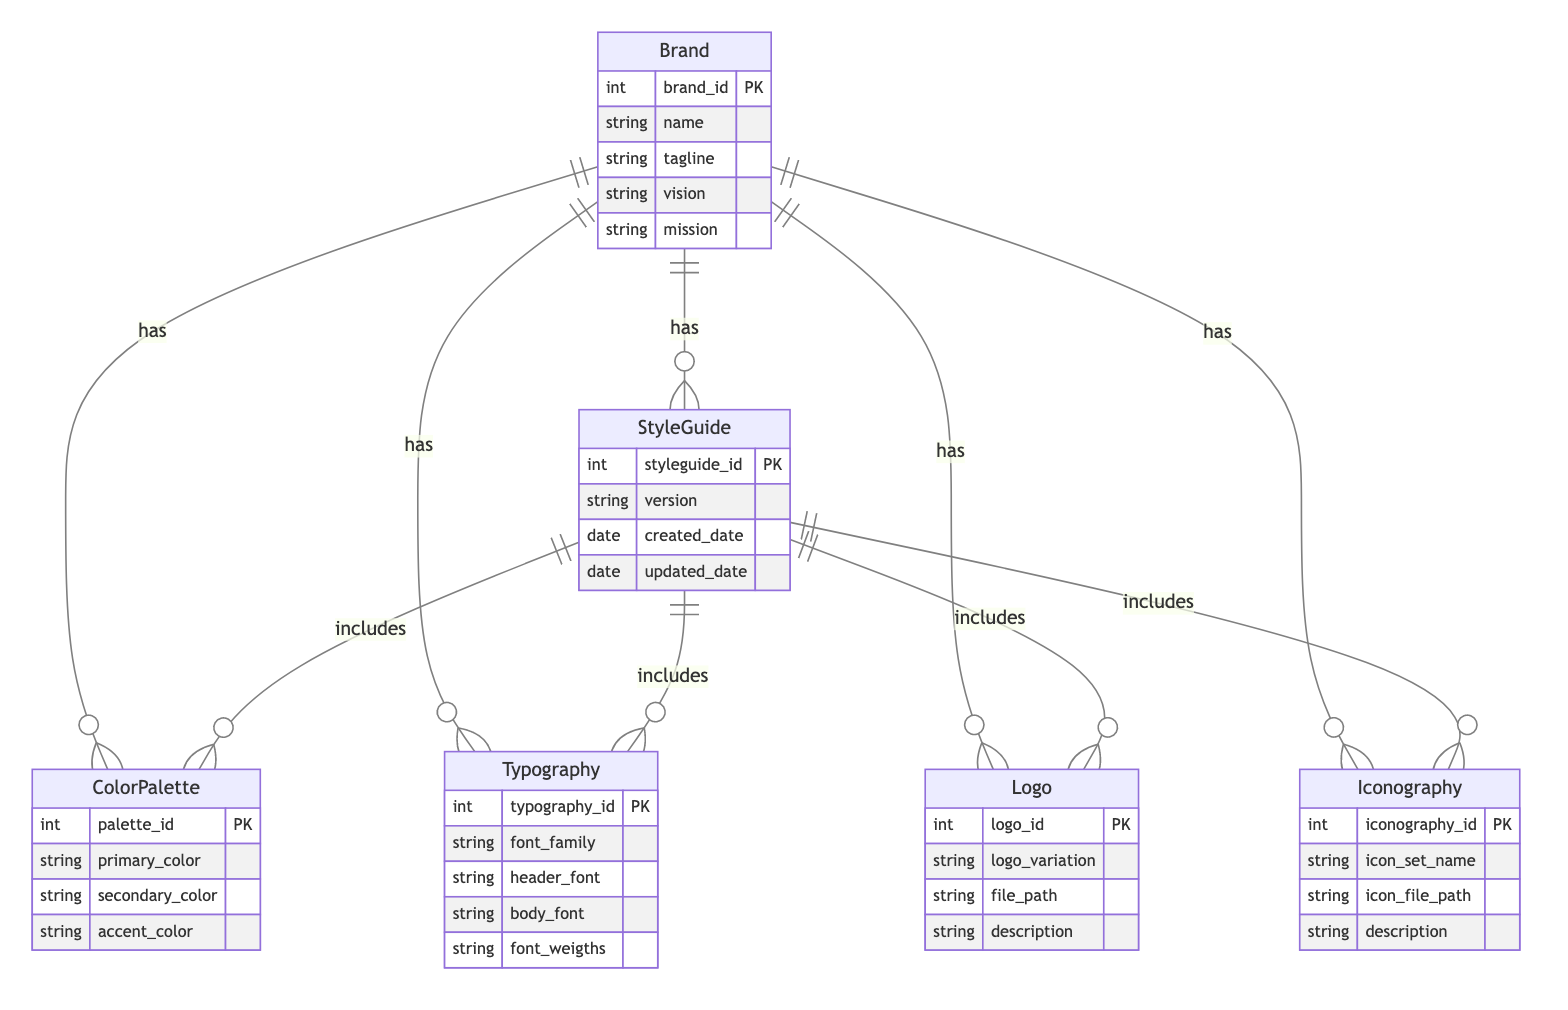What is the primary key of the Brand entity? The primary key of the Brand entity is "brand_id," which uniquely identifies each brand in the database, as indicated in the diagram.
Answer: brand_id How many entities are present in the diagram? The diagram has six entities: Brand, ColorPalette, Typography, Logo, Iconography, and StyleGuide, making a total of six entities.
Answer: six What relationship type exists between Brand and Logo? The relationship between Brand and Logo is one-to-many, meaning one brand can have multiple logos associated with it, as shown in the diagram.
Answer: one-to-many Which entity does the StyleGuide relationship "includes" ColorPalette link back to? The "includes" relationship from ColorPalette links back to the StyleGuide entity, indicating that StyleGuide contains ColorPalette among its elements.
Answer: StyleGuide How many color palettes can a single Brand have? A single Brand can have multiple color palettes due to the one-to-many relationship, thus the number is not limited to one.
Answer: multiple What is the relationship type between StyleGuide and Typography? The relationship type between StyleGuide and Typography is one-to-many, which indicates that one StyleGuide can include more than one Typography styling.
Answer: one-to-many What is the primary attribute of the Iconography entity? The primary attribute of the Iconography entity is "iconography_id," which serves as the unique identifier for each iconography entry in the diagram.
Answer: iconography_id Which entity is associated with the Logo entity through a one-to-many relationship? The Logo entity is associated with the Brand entity through a one-to-many relationship, allowing one brand to have multiple logos.
Answer: Brand What is the purpose of the relationship named BrandHasStyleGuide? The BrandHasStyleGuide relationship indicates that a Brand can have multiple Style Guides, giving flexibility in branding guidelines across various materials.
Answer: flexibility in branding guidelines 